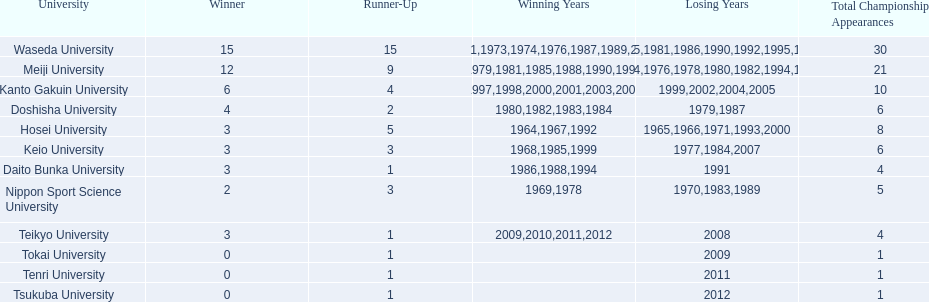What are all of the universities? Waseda University, Meiji University, Kanto Gakuin University, Doshisha University, Hosei University, Keio University, Daito Bunka University, Nippon Sport Science University, Teikyo University, Tokai University, Tenri University, Tsukuba University. And their scores? 15, 12, 6, 4, 3, 3, 3, 2, 3, 0, 0, 0. Which university scored won the most? Waseda University. 